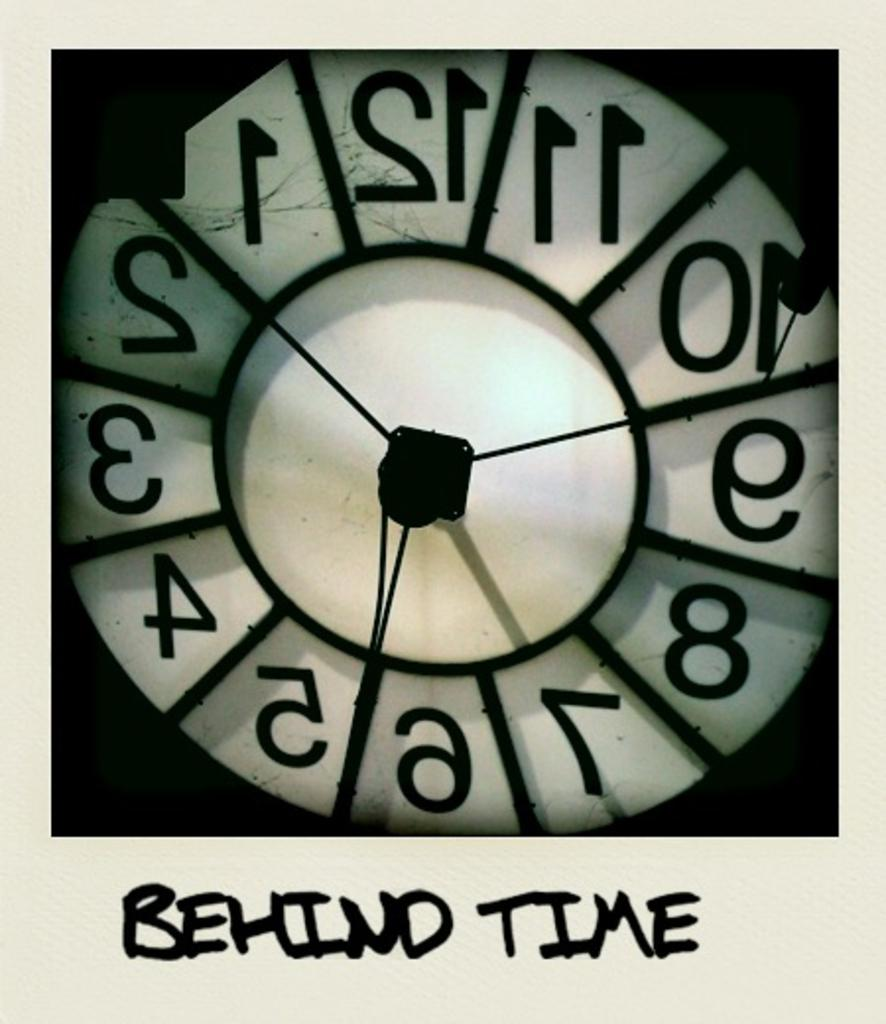Provide a one-sentence caption for the provided image. behind time is written below the clock that is white. 